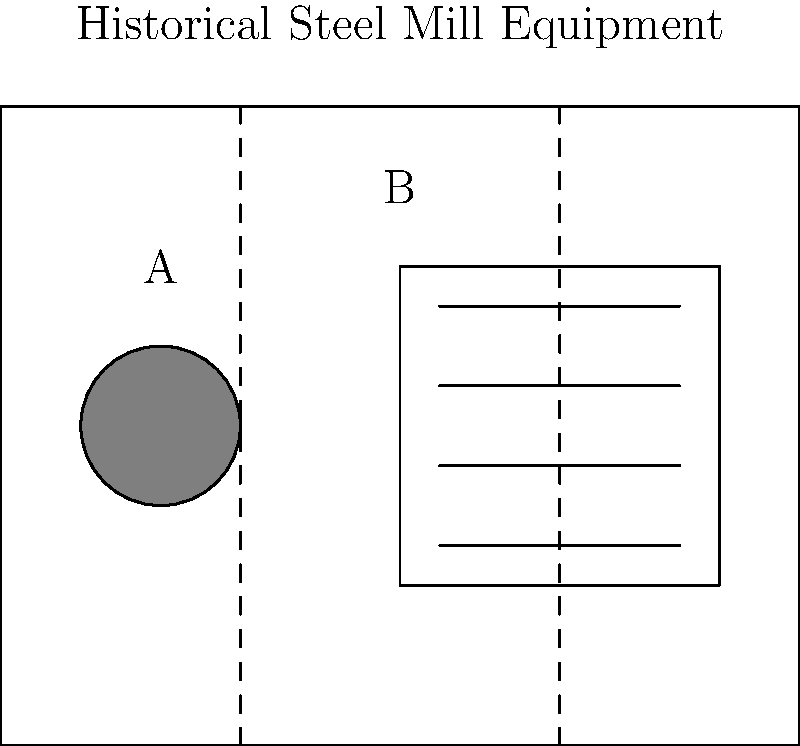In this simplified diagram of a historical steel mill, which piece of equipment is most likely to represent a blast furnace? To identify the blast furnace in this historical steel mill diagram, let's analyze the equipment shown:

1. Equipment A: This is represented by a circular shape, which is characteristic of a blast furnace. Blast furnaces are typically large, cylindrical structures used to smelt iron ore into pig iron.

2. Equipment B: This is depicted as a rectangular structure with multiple horizontal lines, which could represent a rolling mill or a series of processing stations.

3. Blast furnaces are crucial in steel production, as they are used to create the initial iron product that is then refined into steel. Their circular design allows for efficient heat distribution and material flow.

4. The placement of Equipment A at the beginning of the production line (on the left side of the diagram) is consistent with the role of a blast furnace in the steelmaking process.

5. The circular shape of Equipment A also suggests a vessel that can withstand high temperatures and pressures, which are necessary for the iron smelting process in a blast furnace.

Given these observations, Equipment A is most likely to represent a blast furnace in this historical steel mill diagram.
Answer: Equipment A 